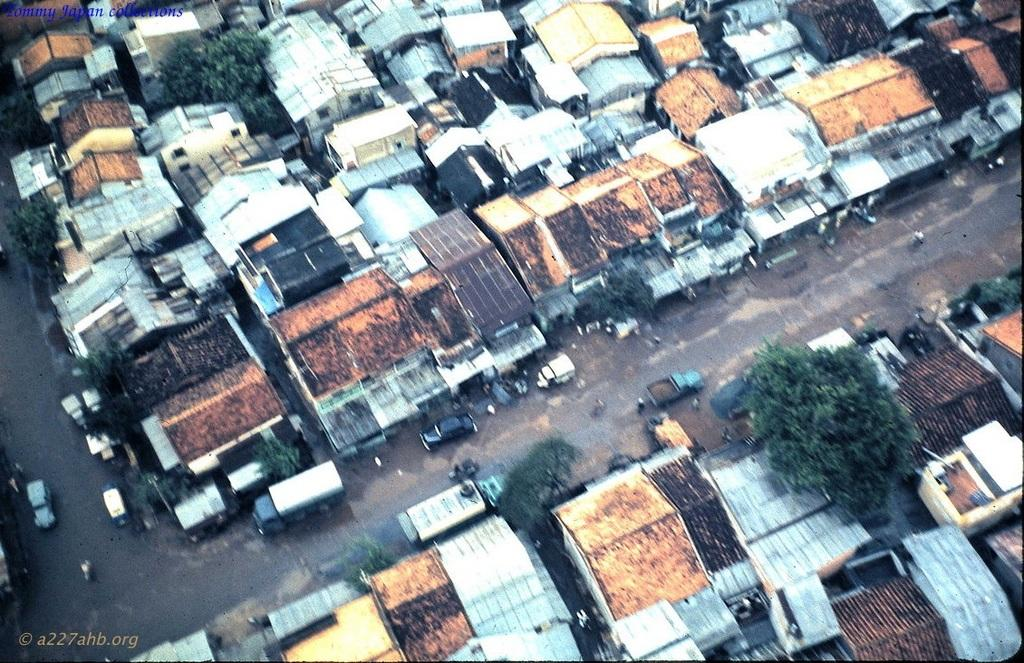What type of view is shown in the image? The image is an aerial view of a village. What can be seen on either side of the land in the image? There are many buildings on either side of the land. What is in the middle of the land in the image? There is a road in the middle of the land. What is happening on the road in the image? Vehicles are moving on the road. What type of jam is being served at the village festival in the image? There is no village festival or jam present in the image. What kind of marble is used to decorate the buildings in the image? There is no mention of marble being used to decorate the buildings in the image. 